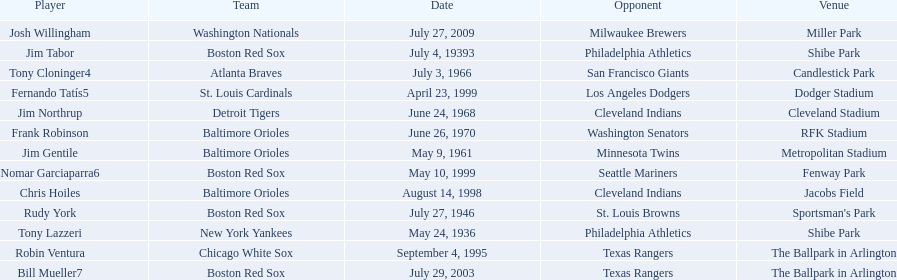Who were all of the players? Tony Lazzeri, Jim Tabor, Rudy York, Jim Gentile, Tony Cloninger4, Jim Northrup, Frank Robinson, Robin Ventura, Chris Hoiles, Fernando Tatís5, Nomar Garciaparra6, Bill Mueller7, Josh Willingham. What year was there a player for the yankees? May 24, 1936. What was the name of that 1936 yankees player? Tony Lazzeri. 